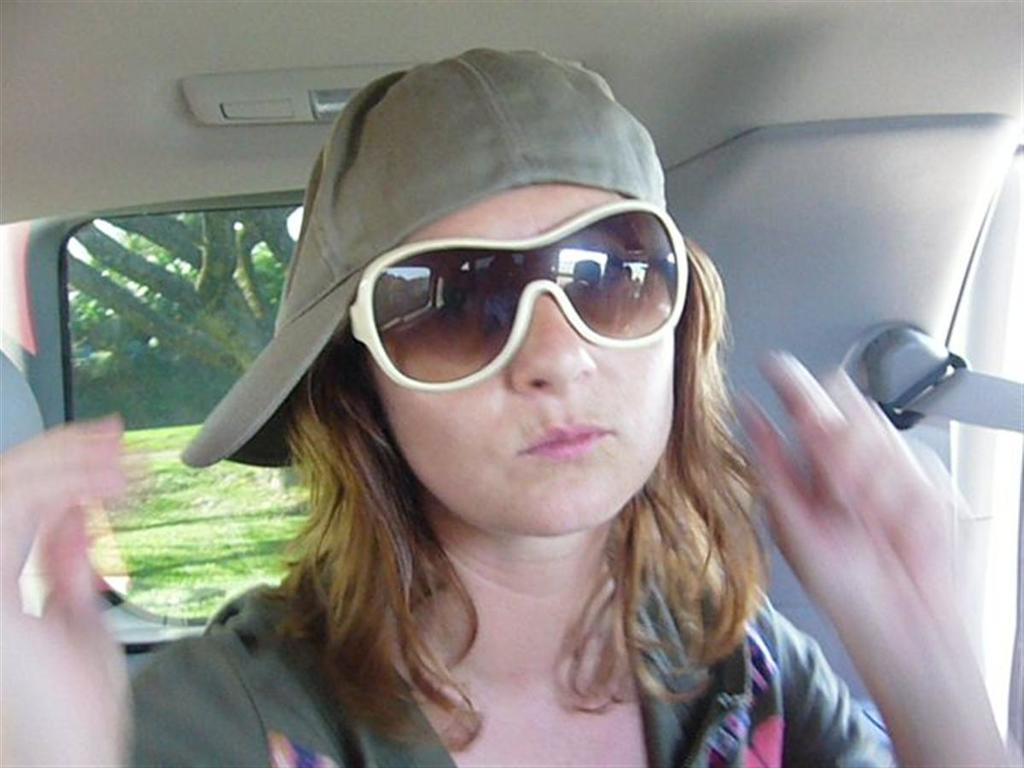How would you summarize this image in a sentence or two? This image is clicked inside a car. There is a woman in the middle. She is wearing goggles and cap. 